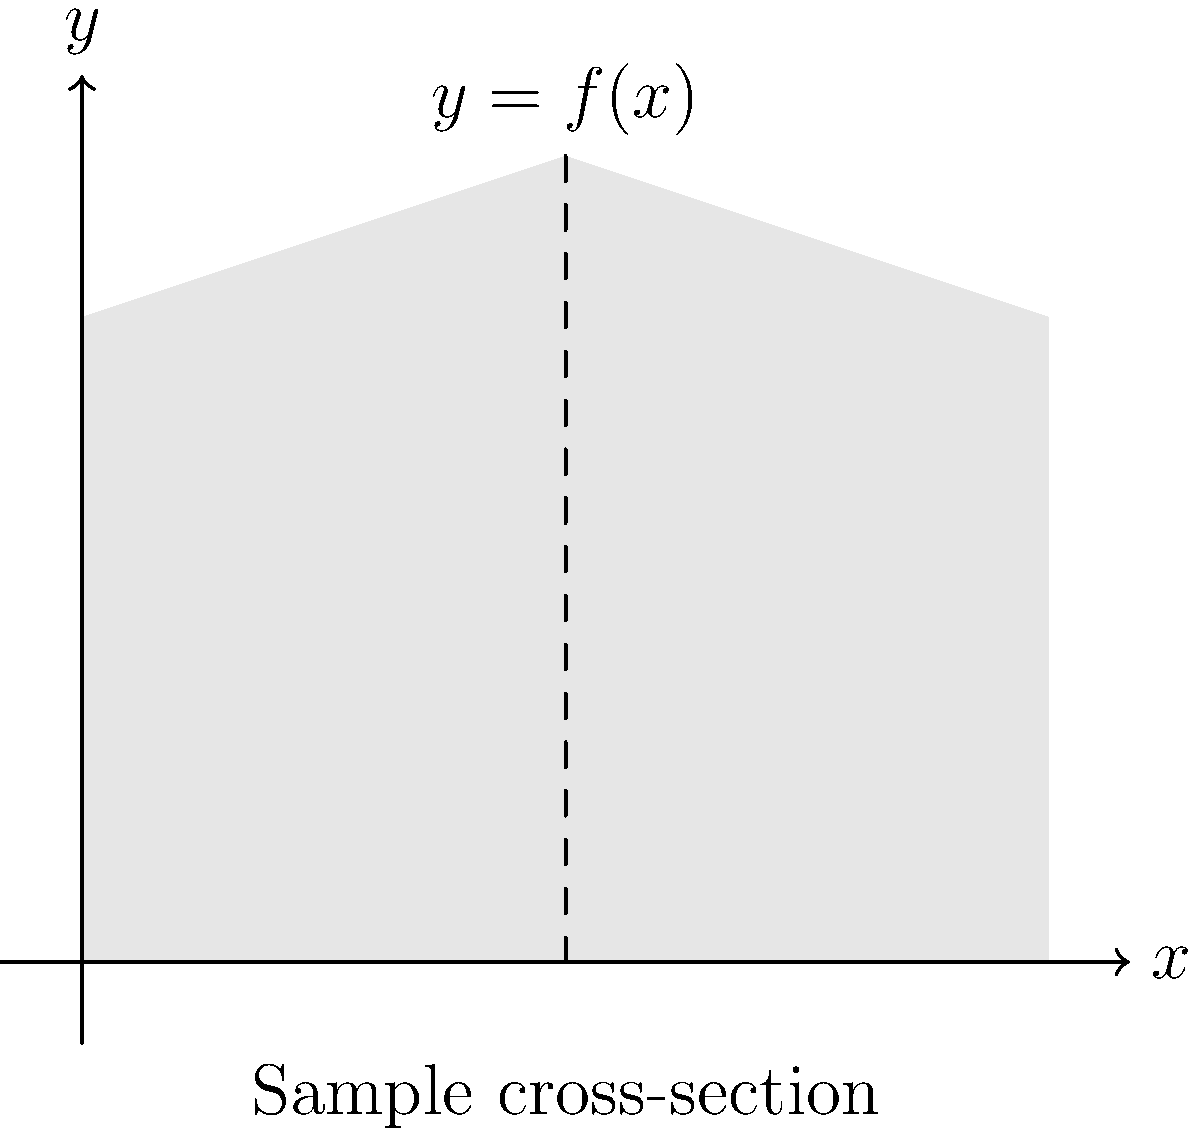A revolutionary new stringed instrument has a unique body shape. When viewed from the side, the cross-section of the instrument's body can be described by the function $f(x) = 4 + x - \frac{x^2}{6}$ for $0 \leq x \leq 6$. If you were to calculate the volume of this instrument's body by rotating this cross-section around the x-axis, what would be the result? Express your answer in terms of $\pi$ cubic units. To find the volume of the instrument's body, we need to use the washer method of integration. Here's how we proceed:

1) The volume of a solid of revolution around the x-axis is given by:
   $$V = \pi \int_a^b [f(x)]^2 dx$$

2) In this case, $a=0$, $b=6$, and $f(x) = 4 + x - \frac{x^2}{6}$. Let's substitute these into the formula:
   $$V = \pi \int_0^6 \left(4 + x - \frac{x^2}{6}\right)^2 dx$$

3) Expand the squared term:
   $$V = \pi \int_0^6 \left(16 + 8x - \frac{4x^2}{3} + x^2 - \frac{x^3}{3} + \frac{x^4}{36}\right) dx$$

4) Integrate term by term:
   $$V = \pi \left[16x + 4x^2 - \frac{4x^3}{9} + \frac{x^3}{3} - \frac{x^4}{12} + \frac{x^5}{180}\right]_0^6$$

5) Evaluate at the limits:
   $$V = \pi \left[(96 + 144 - 96 + 72 - 108 + 43.2) - (0)\right]$$

6) Simplify:
   $$V = 151.2\pi$$

Therefore, the volume of the instrument's body is $151.2\pi$ cubic units.
Answer: $151.2\pi$ cubic units 